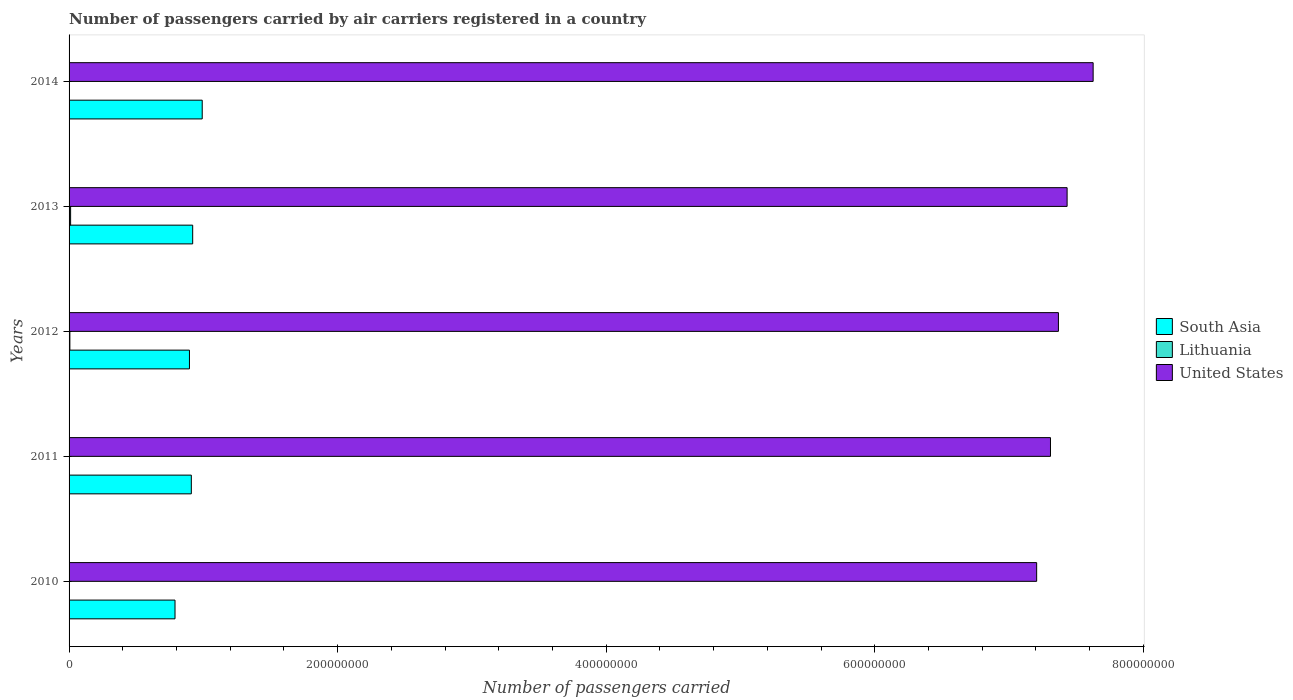How many groups of bars are there?
Your answer should be compact. 5. Are the number of bars per tick equal to the number of legend labels?
Provide a succinct answer. Yes. Are the number of bars on each tick of the Y-axis equal?
Offer a terse response. Yes. How many bars are there on the 1st tick from the top?
Provide a short and direct response. 3. How many bars are there on the 2nd tick from the bottom?
Your answer should be compact. 3. What is the number of passengers carried by air carriers in United States in 2010?
Provide a succinct answer. 7.20e+08. Across all years, what is the maximum number of passengers carried by air carriers in United States?
Provide a succinct answer. 7.63e+08. Across all years, what is the minimum number of passengers carried by air carriers in Lithuania?
Keep it short and to the point. 6.94e+04. In which year was the number of passengers carried by air carriers in Lithuania maximum?
Your answer should be compact. 2013. What is the total number of passengers carried by air carriers in Lithuania in the graph?
Your response must be concise. 2.10e+06. What is the difference between the number of passengers carried by air carriers in South Asia in 2010 and that in 2013?
Keep it short and to the point. -1.32e+07. What is the difference between the number of passengers carried by air carriers in United States in 2010 and the number of passengers carried by air carriers in South Asia in 2012?
Ensure brevity in your answer.  6.31e+08. What is the average number of passengers carried by air carriers in South Asia per year?
Provide a succinct answer. 9.02e+07. In the year 2012, what is the difference between the number of passengers carried by air carriers in Lithuania and number of passengers carried by air carriers in South Asia?
Your answer should be very brief. -8.91e+07. In how many years, is the number of passengers carried by air carriers in Lithuania greater than 640000000 ?
Ensure brevity in your answer.  0. What is the ratio of the number of passengers carried by air carriers in South Asia in 2012 to that in 2014?
Give a very brief answer. 0.9. Is the number of passengers carried by air carriers in South Asia in 2012 less than that in 2014?
Ensure brevity in your answer.  Yes. Is the difference between the number of passengers carried by air carriers in Lithuania in 2011 and 2014 greater than the difference between the number of passengers carried by air carriers in South Asia in 2011 and 2014?
Keep it short and to the point. Yes. What is the difference between the highest and the second highest number of passengers carried by air carriers in United States?
Keep it short and to the point. 1.94e+07. What is the difference between the highest and the lowest number of passengers carried by air carriers in United States?
Your answer should be very brief. 4.21e+07. In how many years, is the number of passengers carried by air carriers in Lithuania greater than the average number of passengers carried by air carriers in Lithuania taken over all years?
Make the answer very short. 2. Is the sum of the number of passengers carried by air carriers in United States in 2010 and 2011 greater than the maximum number of passengers carried by air carriers in South Asia across all years?
Provide a short and direct response. Yes. What does the 3rd bar from the top in 2011 represents?
Provide a short and direct response. South Asia. Is it the case that in every year, the sum of the number of passengers carried by air carriers in Lithuania and number of passengers carried by air carriers in United States is greater than the number of passengers carried by air carriers in South Asia?
Give a very brief answer. Yes. How many bars are there?
Ensure brevity in your answer.  15. How many years are there in the graph?
Provide a succinct answer. 5. Are the values on the major ticks of X-axis written in scientific E-notation?
Ensure brevity in your answer.  No. Does the graph contain grids?
Provide a succinct answer. No. How many legend labels are there?
Provide a succinct answer. 3. How are the legend labels stacked?
Your answer should be compact. Vertical. What is the title of the graph?
Ensure brevity in your answer.  Number of passengers carried by air carriers registered in a country. What is the label or title of the X-axis?
Your answer should be very brief. Number of passengers carried. What is the Number of passengers carried in South Asia in 2010?
Your answer should be very brief. 7.89e+07. What is the Number of passengers carried in Lithuania in 2010?
Provide a succinct answer. 8.14e+04. What is the Number of passengers carried of United States in 2010?
Your response must be concise. 7.20e+08. What is the Number of passengers carried of South Asia in 2011?
Give a very brief answer. 9.10e+07. What is the Number of passengers carried of Lithuania in 2011?
Your answer should be very brief. 6.94e+04. What is the Number of passengers carried of United States in 2011?
Your answer should be very brief. 7.31e+08. What is the Number of passengers carried in South Asia in 2012?
Offer a very short reply. 8.96e+07. What is the Number of passengers carried in Lithuania in 2012?
Provide a succinct answer. 5.93e+05. What is the Number of passengers carried of United States in 2012?
Your answer should be very brief. 7.37e+08. What is the Number of passengers carried in South Asia in 2013?
Give a very brief answer. 9.21e+07. What is the Number of passengers carried in Lithuania in 2013?
Give a very brief answer. 1.14e+06. What is the Number of passengers carried in United States in 2013?
Give a very brief answer. 7.43e+08. What is the Number of passengers carried of South Asia in 2014?
Give a very brief answer. 9.91e+07. What is the Number of passengers carried in Lithuania in 2014?
Make the answer very short. 2.18e+05. What is the Number of passengers carried of United States in 2014?
Ensure brevity in your answer.  7.63e+08. Across all years, what is the maximum Number of passengers carried of South Asia?
Provide a succinct answer. 9.91e+07. Across all years, what is the maximum Number of passengers carried in Lithuania?
Make the answer very short. 1.14e+06. Across all years, what is the maximum Number of passengers carried of United States?
Provide a short and direct response. 7.63e+08. Across all years, what is the minimum Number of passengers carried in South Asia?
Make the answer very short. 7.89e+07. Across all years, what is the minimum Number of passengers carried in Lithuania?
Offer a very short reply. 6.94e+04. Across all years, what is the minimum Number of passengers carried in United States?
Ensure brevity in your answer.  7.20e+08. What is the total Number of passengers carried of South Asia in the graph?
Your answer should be compact. 4.51e+08. What is the total Number of passengers carried in Lithuania in the graph?
Make the answer very short. 2.10e+06. What is the total Number of passengers carried in United States in the graph?
Offer a terse response. 3.69e+09. What is the difference between the Number of passengers carried of South Asia in 2010 and that in 2011?
Your response must be concise. -1.21e+07. What is the difference between the Number of passengers carried of Lithuania in 2010 and that in 2011?
Provide a succinct answer. 1.20e+04. What is the difference between the Number of passengers carried in United States in 2010 and that in 2011?
Give a very brief answer. -1.03e+07. What is the difference between the Number of passengers carried of South Asia in 2010 and that in 2012?
Offer a terse response. -1.08e+07. What is the difference between the Number of passengers carried of Lithuania in 2010 and that in 2012?
Provide a short and direct response. -5.12e+05. What is the difference between the Number of passengers carried of United States in 2010 and that in 2012?
Offer a very short reply. -1.62e+07. What is the difference between the Number of passengers carried of South Asia in 2010 and that in 2013?
Offer a terse response. -1.32e+07. What is the difference between the Number of passengers carried in Lithuania in 2010 and that in 2013?
Make the answer very short. -1.06e+06. What is the difference between the Number of passengers carried in United States in 2010 and that in 2013?
Provide a succinct answer. -2.27e+07. What is the difference between the Number of passengers carried in South Asia in 2010 and that in 2014?
Provide a succinct answer. -2.03e+07. What is the difference between the Number of passengers carried in Lithuania in 2010 and that in 2014?
Give a very brief answer. -1.36e+05. What is the difference between the Number of passengers carried of United States in 2010 and that in 2014?
Provide a succinct answer. -4.21e+07. What is the difference between the Number of passengers carried of South Asia in 2011 and that in 2012?
Ensure brevity in your answer.  1.39e+06. What is the difference between the Number of passengers carried of Lithuania in 2011 and that in 2012?
Provide a succinct answer. -5.24e+05. What is the difference between the Number of passengers carried of United States in 2011 and that in 2012?
Give a very brief answer. -5.90e+06. What is the difference between the Number of passengers carried of South Asia in 2011 and that in 2013?
Provide a short and direct response. -1.02e+06. What is the difference between the Number of passengers carried of Lithuania in 2011 and that in 2013?
Keep it short and to the point. -1.07e+06. What is the difference between the Number of passengers carried in United States in 2011 and that in 2013?
Your answer should be very brief. -1.24e+07. What is the difference between the Number of passengers carried of South Asia in 2011 and that in 2014?
Give a very brief answer. -8.12e+06. What is the difference between the Number of passengers carried in Lithuania in 2011 and that in 2014?
Give a very brief answer. -1.48e+05. What is the difference between the Number of passengers carried of United States in 2011 and that in 2014?
Your answer should be compact. -3.18e+07. What is the difference between the Number of passengers carried of South Asia in 2012 and that in 2013?
Your answer should be compact. -2.40e+06. What is the difference between the Number of passengers carried in Lithuania in 2012 and that in 2013?
Your answer should be very brief. -5.48e+05. What is the difference between the Number of passengers carried in United States in 2012 and that in 2013?
Your answer should be compact. -6.47e+06. What is the difference between the Number of passengers carried of South Asia in 2012 and that in 2014?
Keep it short and to the point. -9.50e+06. What is the difference between the Number of passengers carried in Lithuania in 2012 and that in 2014?
Provide a short and direct response. 3.75e+05. What is the difference between the Number of passengers carried in United States in 2012 and that in 2014?
Give a very brief answer. -2.59e+07. What is the difference between the Number of passengers carried of South Asia in 2013 and that in 2014?
Offer a very short reply. -7.10e+06. What is the difference between the Number of passengers carried of Lithuania in 2013 and that in 2014?
Keep it short and to the point. 9.23e+05. What is the difference between the Number of passengers carried in United States in 2013 and that in 2014?
Your response must be concise. -1.94e+07. What is the difference between the Number of passengers carried in South Asia in 2010 and the Number of passengers carried in Lithuania in 2011?
Provide a short and direct response. 7.88e+07. What is the difference between the Number of passengers carried of South Asia in 2010 and the Number of passengers carried of United States in 2011?
Your answer should be very brief. -6.52e+08. What is the difference between the Number of passengers carried of Lithuania in 2010 and the Number of passengers carried of United States in 2011?
Give a very brief answer. -7.31e+08. What is the difference between the Number of passengers carried in South Asia in 2010 and the Number of passengers carried in Lithuania in 2012?
Your response must be concise. 7.83e+07. What is the difference between the Number of passengers carried in South Asia in 2010 and the Number of passengers carried in United States in 2012?
Your answer should be very brief. -6.58e+08. What is the difference between the Number of passengers carried of Lithuania in 2010 and the Number of passengers carried of United States in 2012?
Keep it short and to the point. -7.37e+08. What is the difference between the Number of passengers carried of South Asia in 2010 and the Number of passengers carried of Lithuania in 2013?
Make the answer very short. 7.77e+07. What is the difference between the Number of passengers carried in South Asia in 2010 and the Number of passengers carried in United States in 2013?
Keep it short and to the point. -6.64e+08. What is the difference between the Number of passengers carried in Lithuania in 2010 and the Number of passengers carried in United States in 2013?
Offer a terse response. -7.43e+08. What is the difference between the Number of passengers carried of South Asia in 2010 and the Number of passengers carried of Lithuania in 2014?
Give a very brief answer. 7.87e+07. What is the difference between the Number of passengers carried of South Asia in 2010 and the Number of passengers carried of United States in 2014?
Give a very brief answer. -6.84e+08. What is the difference between the Number of passengers carried in Lithuania in 2010 and the Number of passengers carried in United States in 2014?
Your answer should be compact. -7.62e+08. What is the difference between the Number of passengers carried of South Asia in 2011 and the Number of passengers carried of Lithuania in 2012?
Ensure brevity in your answer.  9.04e+07. What is the difference between the Number of passengers carried in South Asia in 2011 and the Number of passengers carried in United States in 2012?
Your answer should be compact. -6.46e+08. What is the difference between the Number of passengers carried in Lithuania in 2011 and the Number of passengers carried in United States in 2012?
Ensure brevity in your answer.  -7.37e+08. What is the difference between the Number of passengers carried of South Asia in 2011 and the Number of passengers carried of Lithuania in 2013?
Offer a terse response. 8.99e+07. What is the difference between the Number of passengers carried of South Asia in 2011 and the Number of passengers carried of United States in 2013?
Offer a terse response. -6.52e+08. What is the difference between the Number of passengers carried in Lithuania in 2011 and the Number of passengers carried in United States in 2013?
Offer a very short reply. -7.43e+08. What is the difference between the Number of passengers carried of South Asia in 2011 and the Number of passengers carried of Lithuania in 2014?
Ensure brevity in your answer.  9.08e+07. What is the difference between the Number of passengers carried of South Asia in 2011 and the Number of passengers carried of United States in 2014?
Your answer should be very brief. -6.72e+08. What is the difference between the Number of passengers carried of Lithuania in 2011 and the Number of passengers carried of United States in 2014?
Your answer should be compact. -7.62e+08. What is the difference between the Number of passengers carried in South Asia in 2012 and the Number of passengers carried in Lithuania in 2013?
Your response must be concise. 8.85e+07. What is the difference between the Number of passengers carried of South Asia in 2012 and the Number of passengers carried of United States in 2013?
Provide a succinct answer. -6.54e+08. What is the difference between the Number of passengers carried of Lithuania in 2012 and the Number of passengers carried of United States in 2013?
Keep it short and to the point. -7.43e+08. What is the difference between the Number of passengers carried of South Asia in 2012 and the Number of passengers carried of Lithuania in 2014?
Provide a succinct answer. 8.94e+07. What is the difference between the Number of passengers carried in South Asia in 2012 and the Number of passengers carried in United States in 2014?
Keep it short and to the point. -6.73e+08. What is the difference between the Number of passengers carried in Lithuania in 2012 and the Number of passengers carried in United States in 2014?
Your answer should be compact. -7.62e+08. What is the difference between the Number of passengers carried of South Asia in 2013 and the Number of passengers carried of Lithuania in 2014?
Provide a short and direct response. 9.18e+07. What is the difference between the Number of passengers carried in South Asia in 2013 and the Number of passengers carried in United States in 2014?
Make the answer very short. -6.71e+08. What is the difference between the Number of passengers carried in Lithuania in 2013 and the Number of passengers carried in United States in 2014?
Provide a succinct answer. -7.61e+08. What is the average Number of passengers carried of South Asia per year?
Provide a succinct answer. 9.02e+07. What is the average Number of passengers carried of Lithuania per year?
Keep it short and to the point. 4.20e+05. What is the average Number of passengers carried in United States per year?
Provide a succinct answer. 7.39e+08. In the year 2010, what is the difference between the Number of passengers carried in South Asia and Number of passengers carried in Lithuania?
Your answer should be compact. 7.88e+07. In the year 2010, what is the difference between the Number of passengers carried in South Asia and Number of passengers carried in United States?
Your response must be concise. -6.42e+08. In the year 2010, what is the difference between the Number of passengers carried of Lithuania and Number of passengers carried of United States?
Make the answer very short. -7.20e+08. In the year 2011, what is the difference between the Number of passengers carried in South Asia and Number of passengers carried in Lithuania?
Your answer should be very brief. 9.10e+07. In the year 2011, what is the difference between the Number of passengers carried of South Asia and Number of passengers carried of United States?
Offer a very short reply. -6.40e+08. In the year 2011, what is the difference between the Number of passengers carried in Lithuania and Number of passengers carried in United States?
Keep it short and to the point. -7.31e+08. In the year 2012, what is the difference between the Number of passengers carried of South Asia and Number of passengers carried of Lithuania?
Offer a terse response. 8.91e+07. In the year 2012, what is the difference between the Number of passengers carried in South Asia and Number of passengers carried in United States?
Provide a short and direct response. -6.47e+08. In the year 2012, what is the difference between the Number of passengers carried of Lithuania and Number of passengers carried of United States?
Your answer should be compact. -7.36e+08. In the year 2013, what is the difference between the Number of passengers carried of South Asia and Number of passengers carried of Lithuania?
Offer a terse response. 9.09e+07. In the year 2013, what is the difference between the Number of passengers carried of South Asia and Number of passengers carried of United States?
Offer a terse response. -6.51e+08. In the year 2013, what is the difference between the Number of passengers carried of Lithuania and Number of passengers carried of United States?
Your answer should be compact. -7.42e+08. In the year 2014, what is the difference between the Number of passengers carried of South Asia and Number of passengers carried of Lithuania?
Provide a short and direct response. 9.89e+07. In the year 2014, what is the difference between the Number of passengers carried in South Asia and Number of passengers carried in United States?
Make the answer very short. -6.63e+08. In the year 2014, what is the difference between the Number of passengers carried in Lithuania and Number of passengers carried in United States?
Offer a terse response. -7.62e+08. What is the ratio of the Number of passengers carried of South Asia in 2010 to that in 2011?
Make the answer very short. 0.87. What is the ratio of the Number of passengers carried of Lithuania in 2010 to that in 2011?
Provide a succinct answer. 1.17. What is the ratio of the Number of passengers carried in United States in 2010 to that in 2011?
Keep it short and to the point. 0.99. What is the ratio of the Number of passengers carried in Lithuania in 2010 to that in 2012?
Give a very brief answer. 0.14. What is the ratio of the Number of passengers carried of South Asia in 2010 to that in 2013?
Provide a short and direct response. 0.86. What is the ratio of the Number of passengers carried in Lithuania in 2010 to that in 2013?
Your answer should be very brief. 0.07. What is the ratio of the Number of passengers carried of United States in 2010 to that in 2013?
Your answer should be compact. 0.97. What is the ratio of the Number of passengers carried in South Asia in 2010 to that in 2014?
Keep it short and to the point. 0.8. What is the ratio of the Number of passengers carried of Lithuania in 2010 to that in 2014?
Make the answer very short. 0.37. What is the ratio of the Number of passengers carried in United States in 2010 to that in 2014?
Your response must be concise. 0.94. What is the ratio of the Number of passengers carried in South Asia in 2011 to that in 2012?
Your response must be concise. 1.02. What is the ratio of the Number of passengers carried in Lithuania in 2011 to that in 2012?
Your answer should be compact. 0.12. What is the ratio of the Number of passengers carried of South Asia in 2011 to that in 2013?
Your answer should be very brief. 0.99. What is the ratio of the Number of passengers carried of Lithuania in 2011 to that in 2013?
Provide a short and direct response. 0.06. What is the ratio of the Number of passengers carried of United States in 2011 to that in 2013?
Ensure brevity in your answer.  0.98. What is the ratio of the Number of passengers carried of South Asia in 2011 to that in 2014?
Your answer should be compact. 0.92. What is the ratio of the Number of passengers carried of Lithuania in 2011 to that in 2014?
Make the answer very short. 0.32. What is the ratio of the Number of passengers carried in United States in 2011 to that in 2014?
Ensure brevity in your answer.  0.96. What is the ratio of the Number of passengers carried in South Asia in 2012 to that in 2013?
Your answer should be compact. 0.97. What is the ratio of the Number of passengers carried of Lithuania in 2012 to that in 2013?
Your answer should be compact. 0.52. What is the ratio of the Number of passengers carried in South Asia in 2012 to that in 2014?
Offer a terse response. 0.9. What is the ratio of the Number of passengers carried of Lithuania in 2012 to that in 2014?
Make the answer very short. 2.72. What is the ratio of the Number of passengers carried in United States in 2012 to that in 2014?
Your answer should be very brief. 0.97. What is the ratio of the Number of passengers carried of South Asia in 2013 to that in 2014?
Provide a succinct answer. 0.93. What is the ratio of the Number of passengers carried in Lithuania in 2013 to that in 2014?
Your answer should be very brief. 5.24. What is the ratio of the Number of passengers carried in United States in 2013 to that in 2014?
Your answer should be compact. 0.97. What is the difference between the highest and the second highest Number of passengers carried in South Asia?
Offer a terse response. 7.10e+06. What is the difference between the highest and the second highest Number of passengers carried in Lithuania?
Offer a very short reply. 5.48e+05. What is the difference between the highest and the second highest Number of passengers carried in United States?
Your response must be concise. 1.94e+07. What is the difference between the highest and the lowest Number of passengers carried of South Asia?
Your answer should be very brief. 2.03e+07. What is the difference between the highest and the lowest Number of passengers carried of Lithuania?
Give a very brief answer. 1.07e+06. What is the difference between the highest and the lowest Number of passengers carried in United States?
Offer a very short reply. 4.21e+07. 